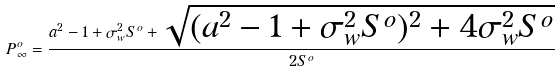Convert formula to latex. <formula><loc_0><loc_0><loc_500><loc_500>P _ { \infty } ^ { o } = \frac { a ^ { 2 } - 1 + \sigma _ { w } ^ { 2 } S ^ { o } + \sqrt { ( a ^ { 2 } - 1 + \sigma _ { w } ^ { 2 } S ^ { o } ) ^ { 2 } + 4 \sigma _ { w } ^ { 2 } S ^ { o } } } { 2 S ^ { o } }</formula> 